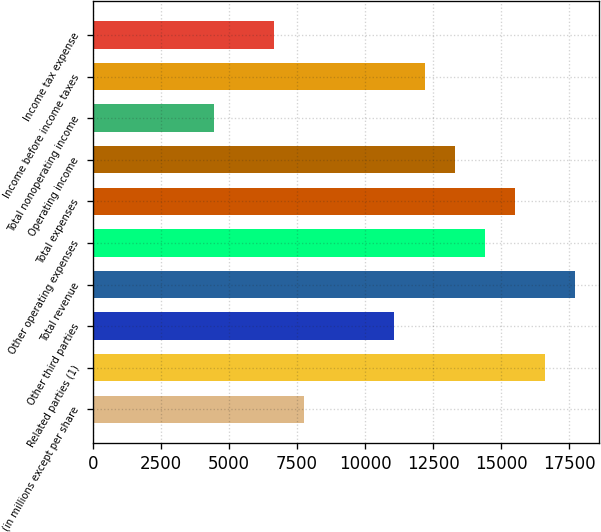Convert chart to OTSL. <chart><loc_0><loc_0><loc_500><loc_500><bar_chart><fcel>(in millions except per share<fcel>Related parties (1)<fcel>Other third parties<fcel>Total revenue<fcel>Other operating expenses<fcel>Total expenses<fcel>Operating income<fcel>Total nonoperating income<fcel>Income before income taxes<fcel>Income tax expense<nl><fcel>7759.03<fcel>16617.7<fcel>11081<fcel>17725<fcel>14403<fcel>15510.3<fcel>13295.7<fcel>4437.04<fcel>12188.4<fcel>6651.7<nl></chart> 